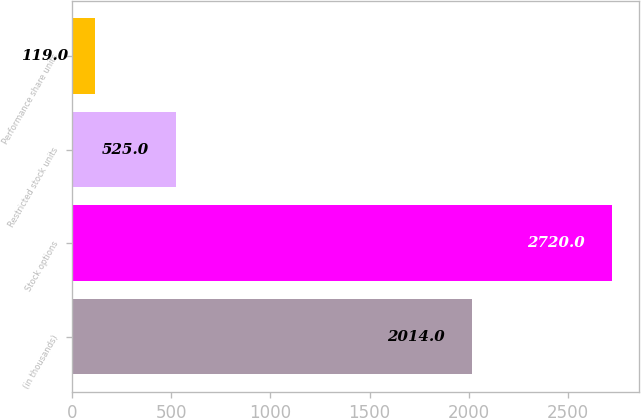<chart> <loc_0><loc_0><loc_500><loc_500><bar_chart><fcel>(in thousands)<fcel>Stock options<fcel>Restricted stock units<fcel>Performance share units<nl><fcel>2014<fcel>2720<fcel>525<fcel>119<nl></chart> 